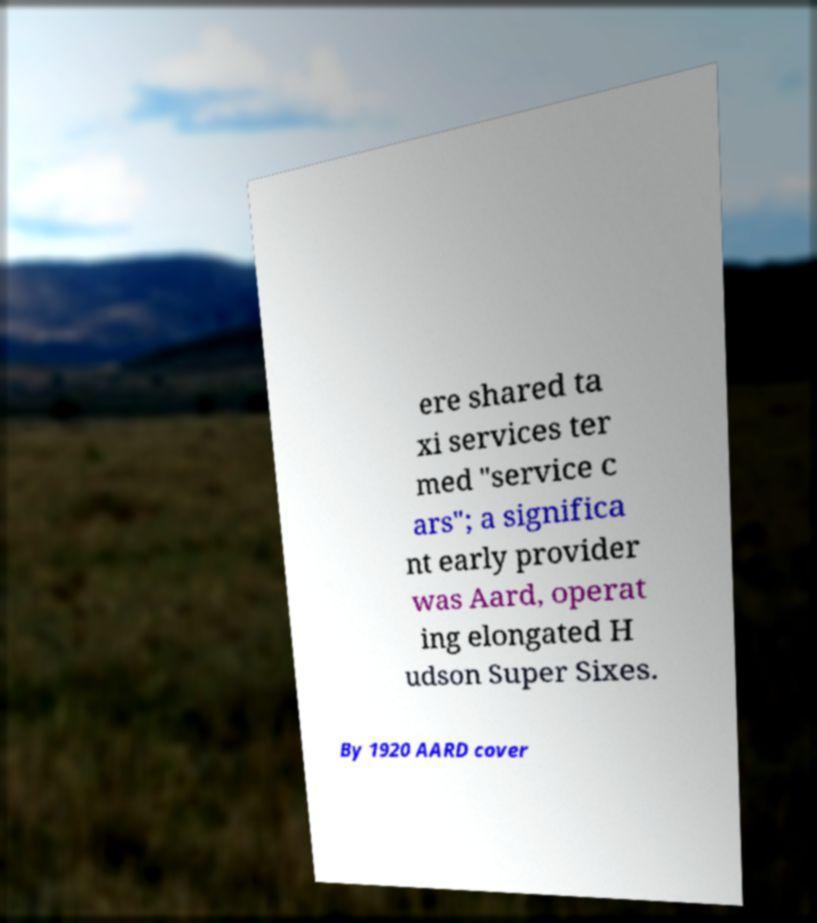Can you read and provide the text displayed in the image?This photo seems to have some interesting text. Can you extract and type it out for me? ere shared ta xi services ter med "service c ars"; a significa nt early provider was Aard, operat ing elongated H udson Super Sixes. By 1920 AARD cover 